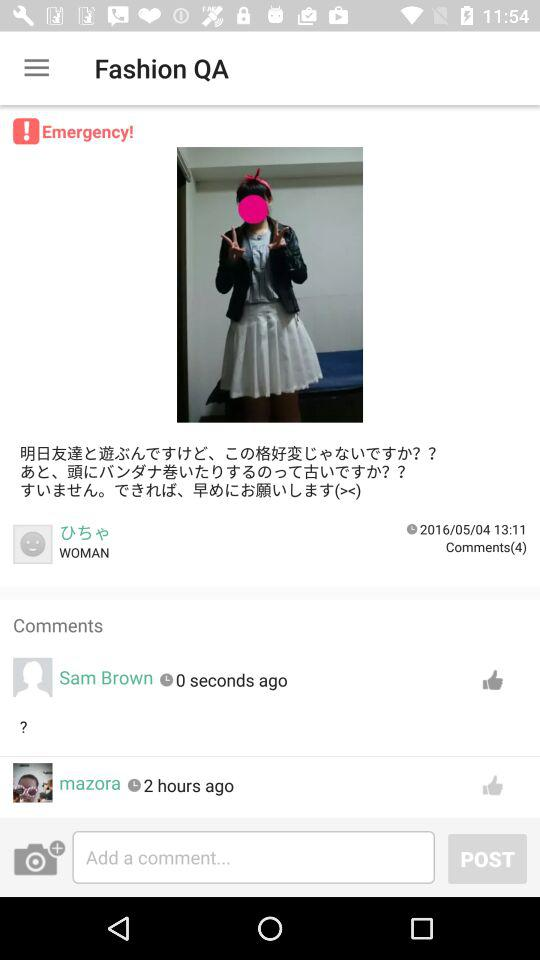How many total comments are there? There are 4 comments. 